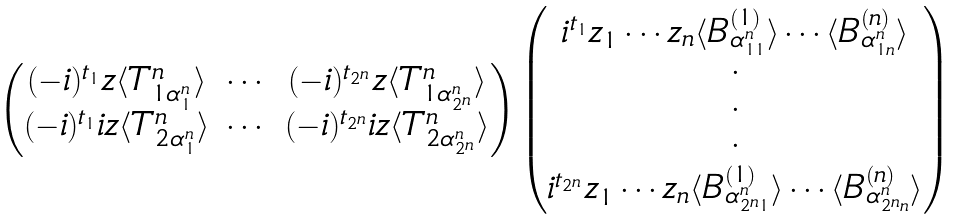Convert formula to latex. <formula><loc_0><loc_0><loc_500><loc_500>\begin{matrix} \begin{pmatrix} ( - i ) ^ { t _ { 1 } } z \langle T _ { 1 \alpha _ { 1 } ^ { n } } ^ { n } \rangle & \cdots & ( - i ) ^ { t _ { 2 ^ { n } } } z \langle T _ { 1 \alpha _ { 2 ^ { n } } ^ { n } } ^ { n } \rangle \\ ( - i ) ^ { t _ { 1 } } i z \langle T _ { 2 \alpha _ { 1 } ^ { n } } ^ { n } \rangle & \cdots & ( - i ) ^ { t _ { 2 ^ { n } } } i z \langle T _ { 2 \alpha _ { 2 ^ { n } } ^ { n } } ^ { n } \rangle \end{pmatrix} \begin{pmatrix} i ^ { t _ { 1 } } z _ { 1 } \cdots z _ { n } \langle B _ { \alpha _ { 1 1 } ^ { n } } ^ { ( 1 ) } \rangle \cdots \langle B _ { \alpha _ { 1 n } ^ { n } } ^ { ( n ) } \rangle \\ \cdot \\ \cdot \\ \cdot \\ i ^ { t _ { 2 ^ { n } } } z _ { 1 } \cdots z _ { n } \langle B _ { \alpha _ { 2 ^ { n } 1 } ^ { n } } ^ { ( 1 ) } \rangle \cdots \langle B _ { \alpha _ { 2 ^ { n } n } ^ { n } } ^ { ( n ) } \rangle \end{pmatrix} \end{matrix}</formula> 